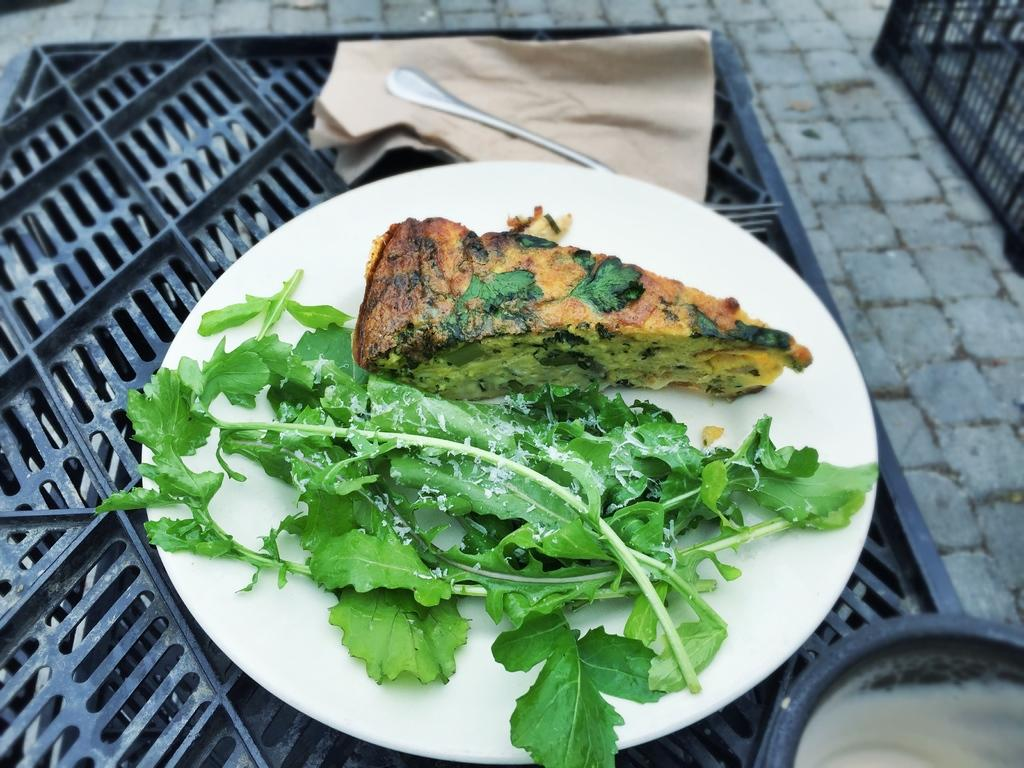What is on the plate that is visible in the image? There is food on a plate in the image. Where is the plate located in the image? The plate is placed on a grill in the image. How is the food and plate positioned in the image? The food and plate are in the center of the image. What type of jelly is being used as a marinade for the food on the plate in the image? There is no jelly present in the image, nor is there any indication that the food is being marinated. What type of oil is being used to cook the food on the plate in the image? There is no oil present in the image, nor is there any indication that the food is being cooked. 